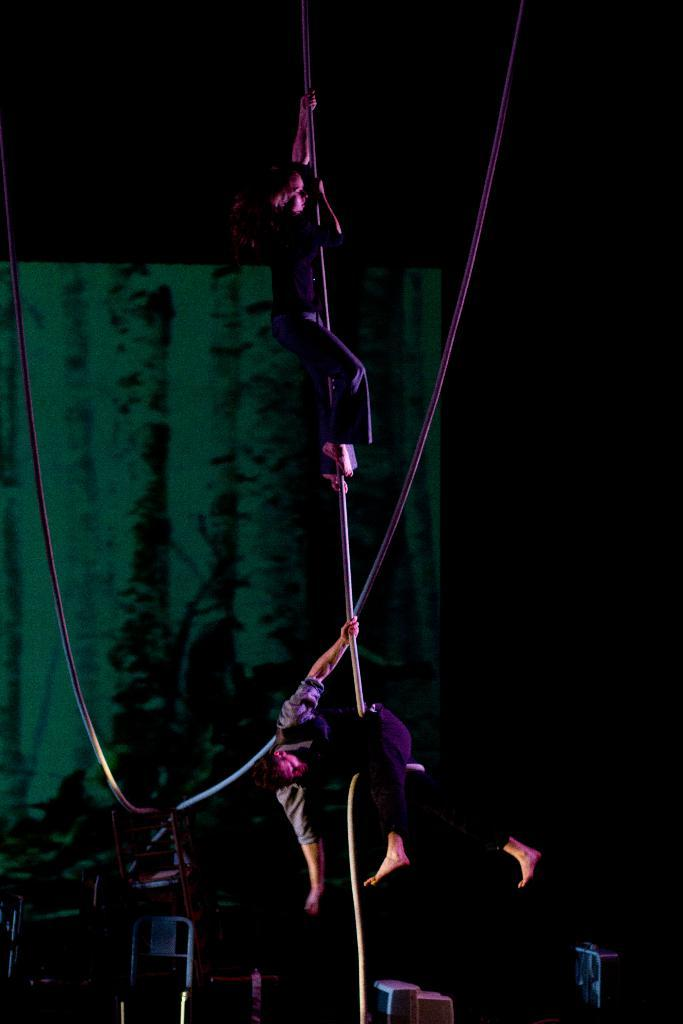How many people are in the image? There are two men in the image. What are the men doing in the image? The men are climbing a rope. Can you describe any other ropes visible in the image? There is another rope visible in the background. What is the color of the curtain in the image? There is a green curtain in the image. What type of bike is leaning against the green curtain in the image? There is no bike present in the image; it only features two men climbing a rope and a green curtain. 